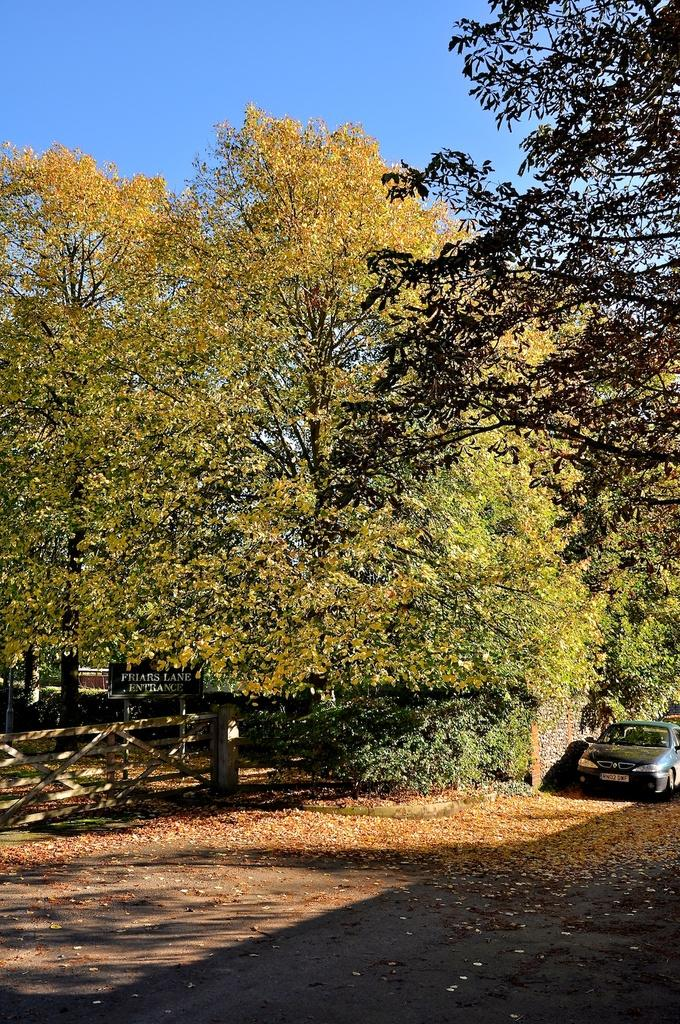What type of natural elements can be seen in the image? There are trees in the image. What man-made object is visible on the right side of the image? There is a vehicle visible on the right side of the image. What type of barrier is present on the left side of the image? There is a fence on the left side of the image. What type of fan is visible in the image? There is no fan present in the image. What type of exchange is taking place between the trees and the vehicle? There is no exchange taking place between the trees and the vehicle in the image. 